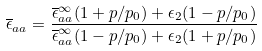<formula> <loc_0><loc_0><loc_500><loc_500>\overline { \epsilon } _ { a a } = \frac { \overline { \epsilon } ^ { \infty } _ { a a } ( 1 + p / p _ { 0 } ) + \epsilon _ { 2 } ( 1 - p / p _ { 0 } ) } { \overline { \epsilon } ^ { \infty } _ { a a } ( 1 - p / p _ { 0 } ) + \epsilon _ { 2 } ( 1 + p / p _ { 0 } ) }</formula> 